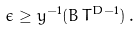<formula> <loc_0><loc_0><loc_500><loc_500>\epsilon \geq y ^ { - 1 } ( B \, T ^ { D - 1 } ) \, .</formula> 